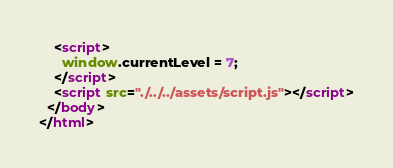Convert code to text. <code><loc_0><loc_0><loc_500><loc_500><_HTML_>    <script>
      window.currentLevel = 7;
    </script>
    <script src="./../../assets/script.js"></script>
  </body>
</html></code> 